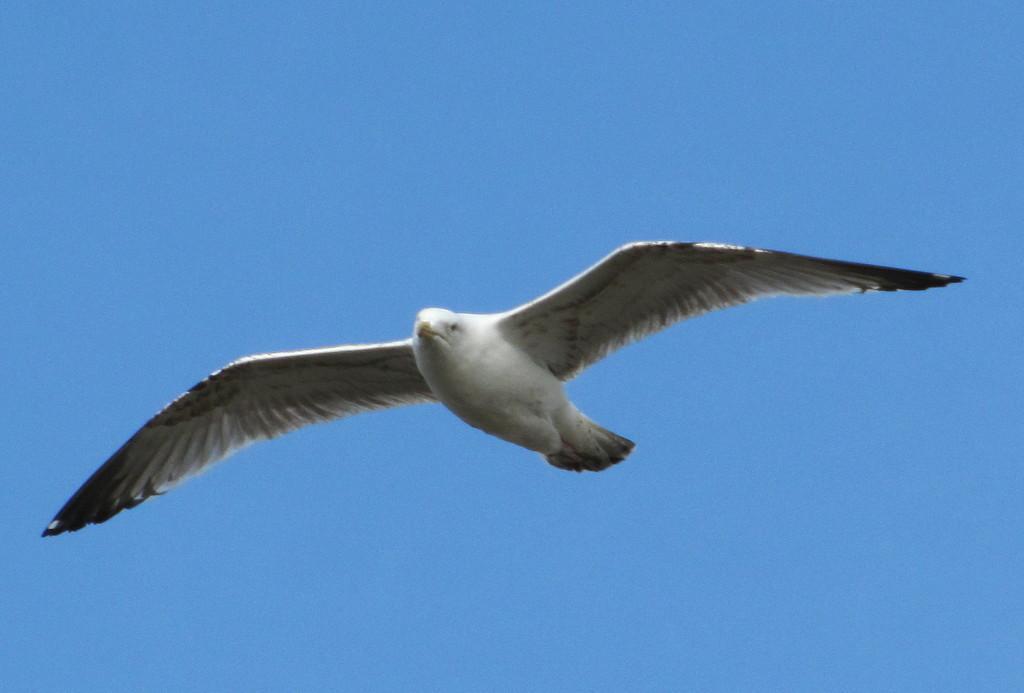In one or two sentences, can you explain what this image depicts? In this image, we can see a bird in the sky. 